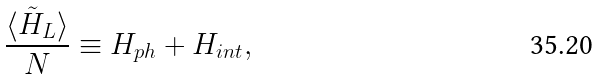Convert formula to latex. <formula><loc_0><loc_0><loc_500><loc_500>\frac { \langle \tilde { H } _ { L } \rangle } { N } \equiv H _ { p h } + H _ { i n t } ,</formula> 